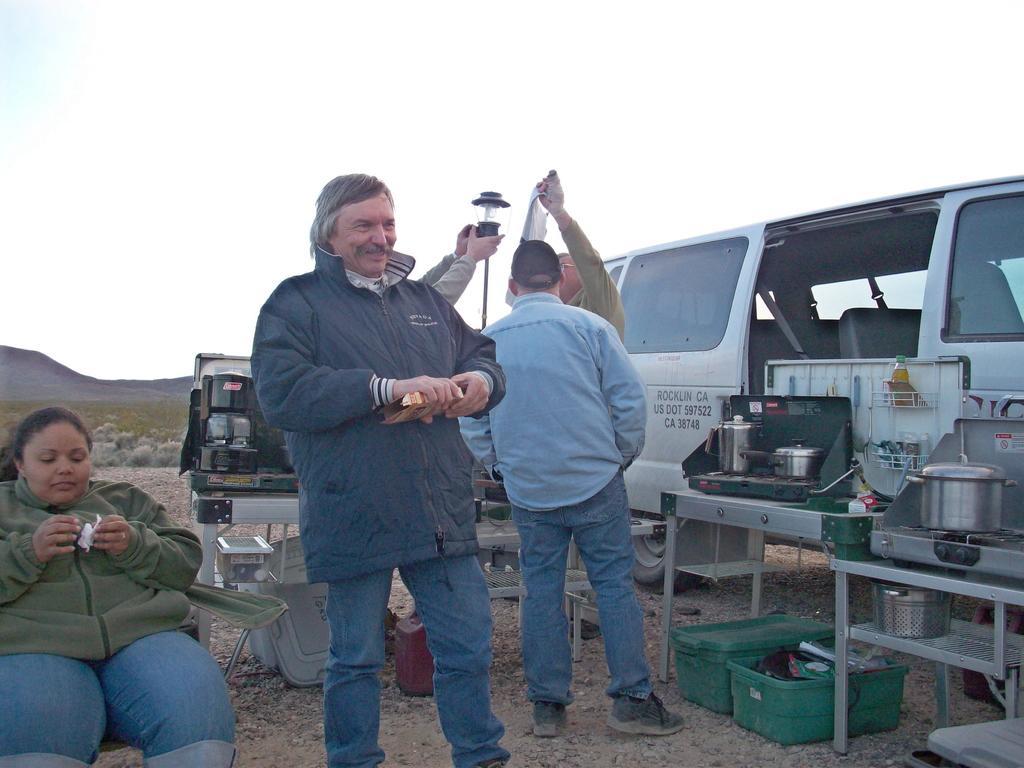In one or two sentences, can you explain what this image depicts? In this image we can see some persons, utensils, vehicle, lamp, chair, tables and other objects. In the background of the image there are mountains, grass, rocks and other objects. At the top of the image there is the sky. 